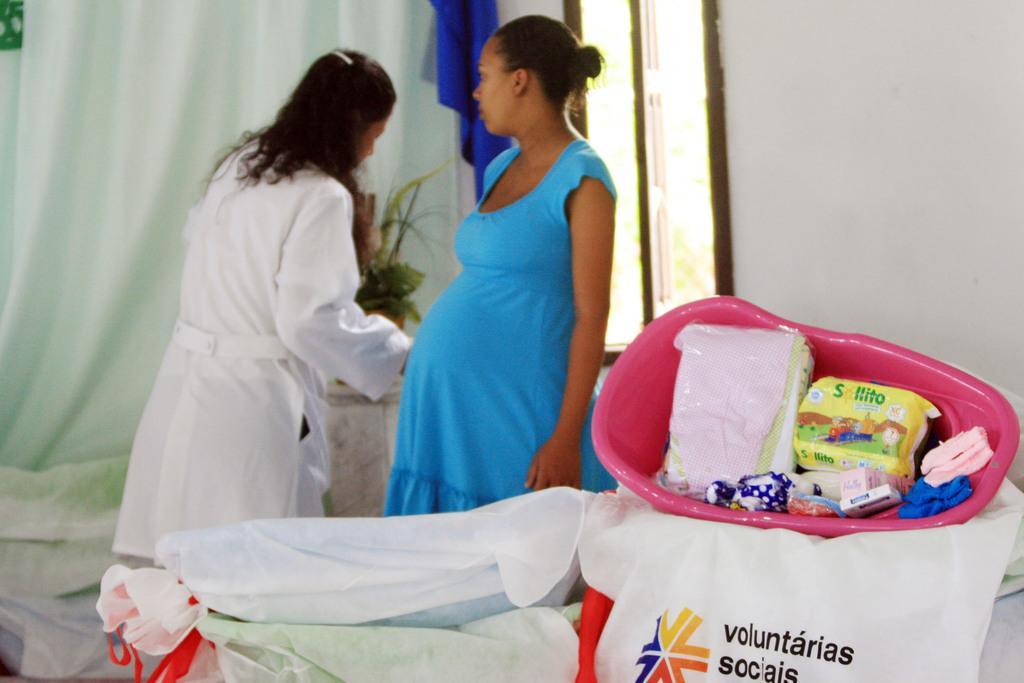Can you describe this image briefly? In this image in the front there is a carry bag with some text written on it and there is a plastic tub with some objects on it. In the center there are persons standing. In the background there is a curtain and there is a window and there is a plant and there is a cloth hanging which is blue in colour. 